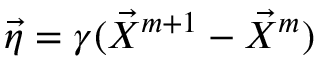Convert formula to latex. <formula><loc_0><loc_0><loc_500><loc_500>\vec { \eta } = \gamma ( \vec { X } ^ { m + 1 } - \vec { X } ^ { m } )</formula> 